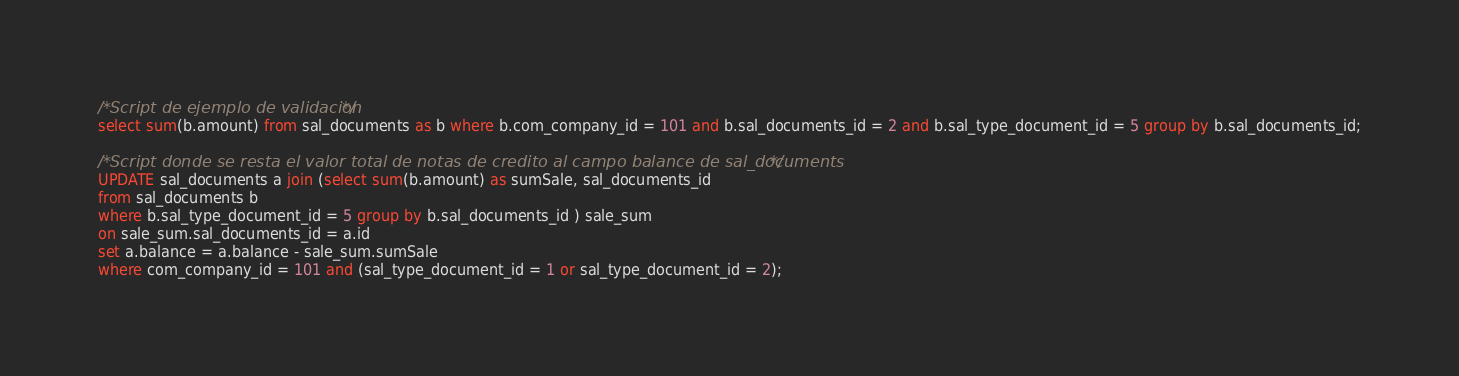Convert code to text. <code><loc_0><loc_0><loc_500><loc_500><_SQL_>
/*Script de ejemplo de validacion */
select sum(b.amount) from sal_documents as b where b.com_company_id = 101 and b.sal_documents_id = 2 and b.sal_type_document_id = 5 group by b.sal_documents_id;

/*Script donde se resta el valor total de notas de credito al campo balance de sal_documents*/
UPDATE sal_documents a join (select sum(b.amount) as sumSale, sal_documents_id
from sal_documents b
where b.sal_type_document_id = 5 group by b.sal_documents_id ) sale_sum
on sale_sum.sal_documents_id = a.id
set a.balance = a.balance - sale_sum.sumSale
where com_company_id = 101 and (sal_type_document_id = 1 or sal_type_document_id = 2);</code> 